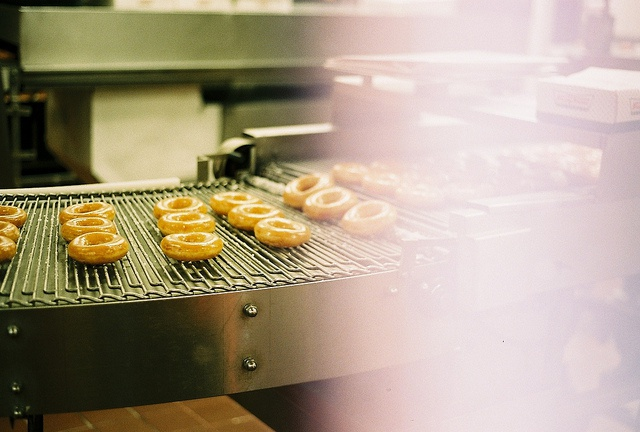Describe the objects in this image and their specific colors. I can see donut in lightgray, tan, and black tones, donut in black, orange, olive, khaki, and tan tones, donut in black, olive, orange, khaki, and tan tones, donut in black, tan, and beige tones, and donut in black, orange, khaki, and olive tones in this image. 